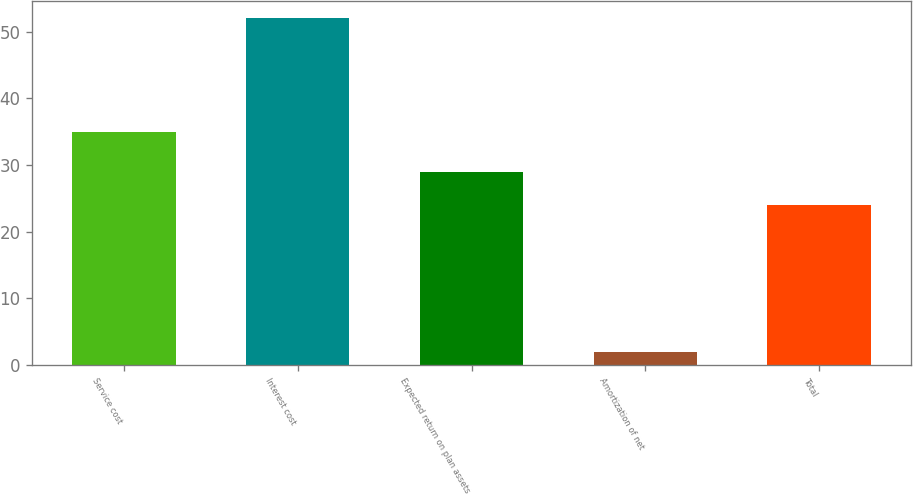Convert chart. <chart><loc_0><loc_0><loc_500><loc_500><bar_chart><fcel>Service cost<fcel>Interest cost<fcel>Expected return on plan assets<fcel>Amortization of net<fcel>Total<nl><fcel>35<fcel>52<fcel>29<fcel>2<fcel>24<nl></chart> 